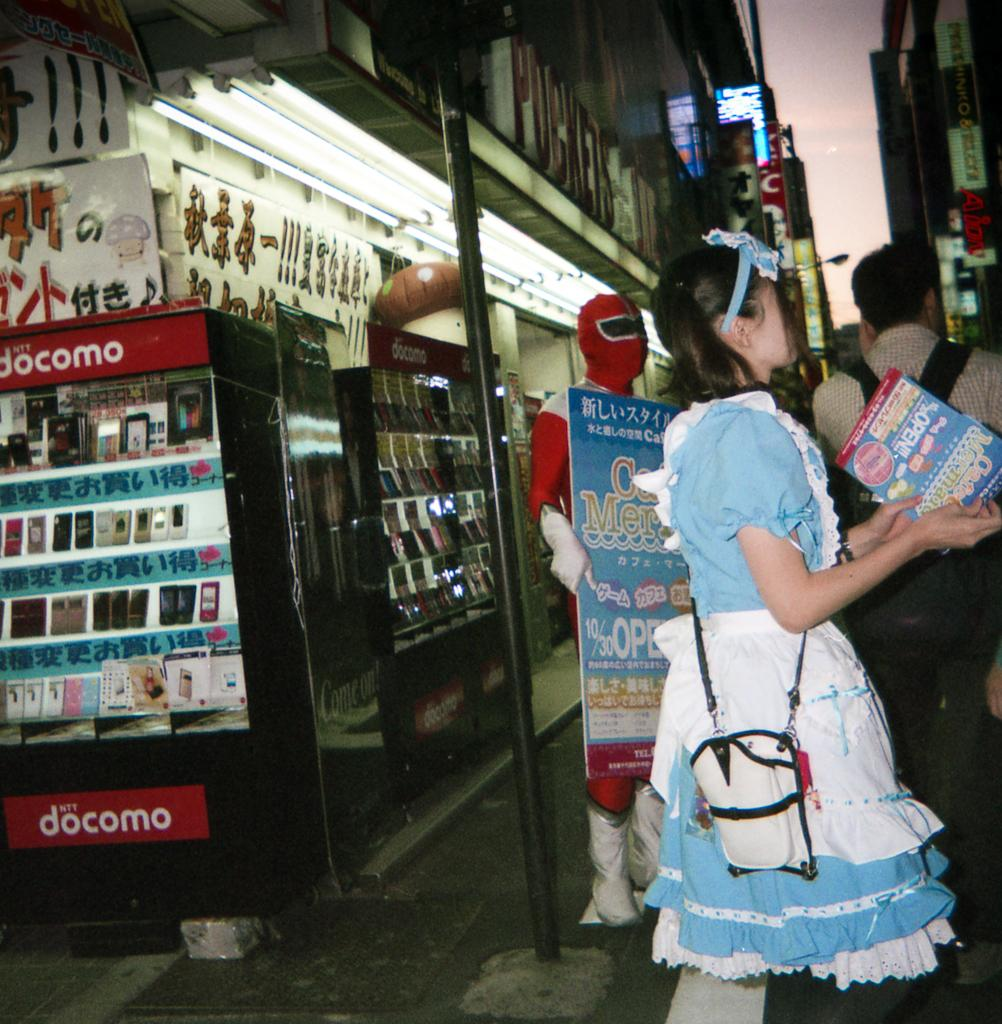<image>
Offer a succinct explanation of the picture presented. A woman wearing an Alice in Wonderland costume stands outside of a Docomo store 